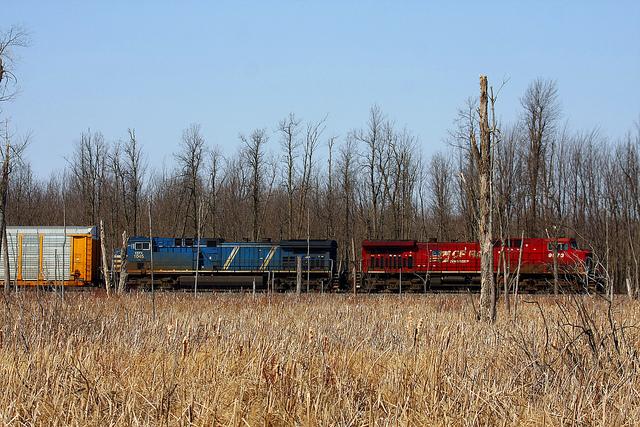What is the color of the train in the front?
Keep it brief. Red. How many trees are behind the train?
Concise answer only. Many. Is this a passenger train?
Give a very brief answer. No. 